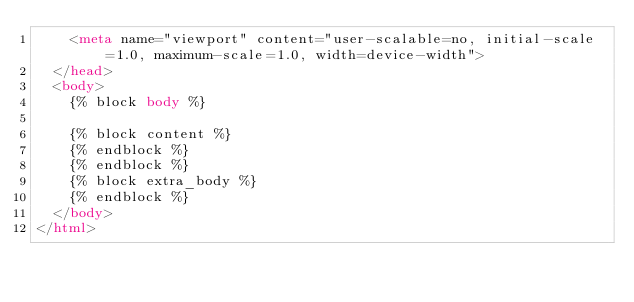Convert code to text. <code><loc_0><loc_0><loc_500><loc_500><_HTML_>    <meta name="viewport" content="user-scalable=no, initial-scale=1.0, maximum-scale=1.0, width=device-width">
  </head>
  <body>
    {% block body %}

    {% block content %}
    {% endblock %}
    {% endblock %}
    {% block extra_body %}
    {% endblock %}
  </body>
</html>
</code> 